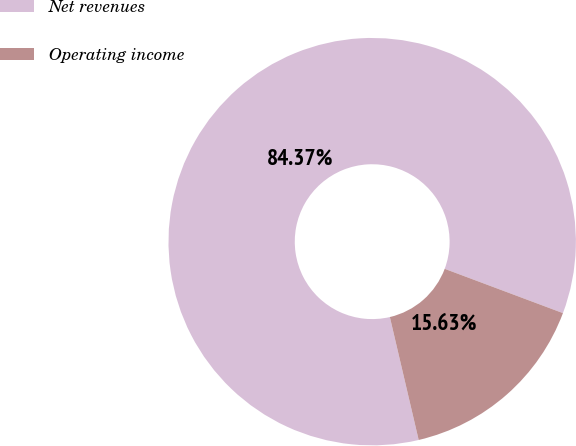<chart> <loc_0><loc_0><loc_500><loc_500><pie_chart><fcel>Net revenues<fcel>Operating income<nl><fcel>84.37%<fcel>15.63%<nl></chart> 